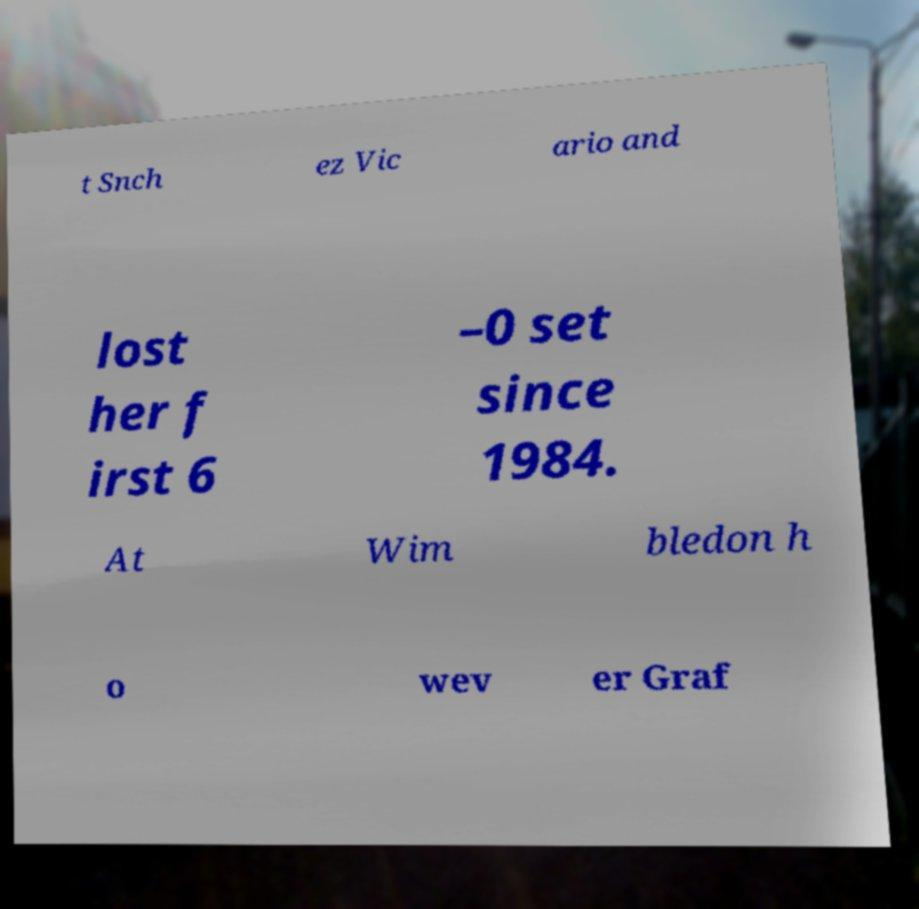I need the written content from this picture converted into text. Can you do that? t Snch ez Vic ario and lost her f irst 6 –0 set since 1984. At Wim bledon h o wev er Graf 